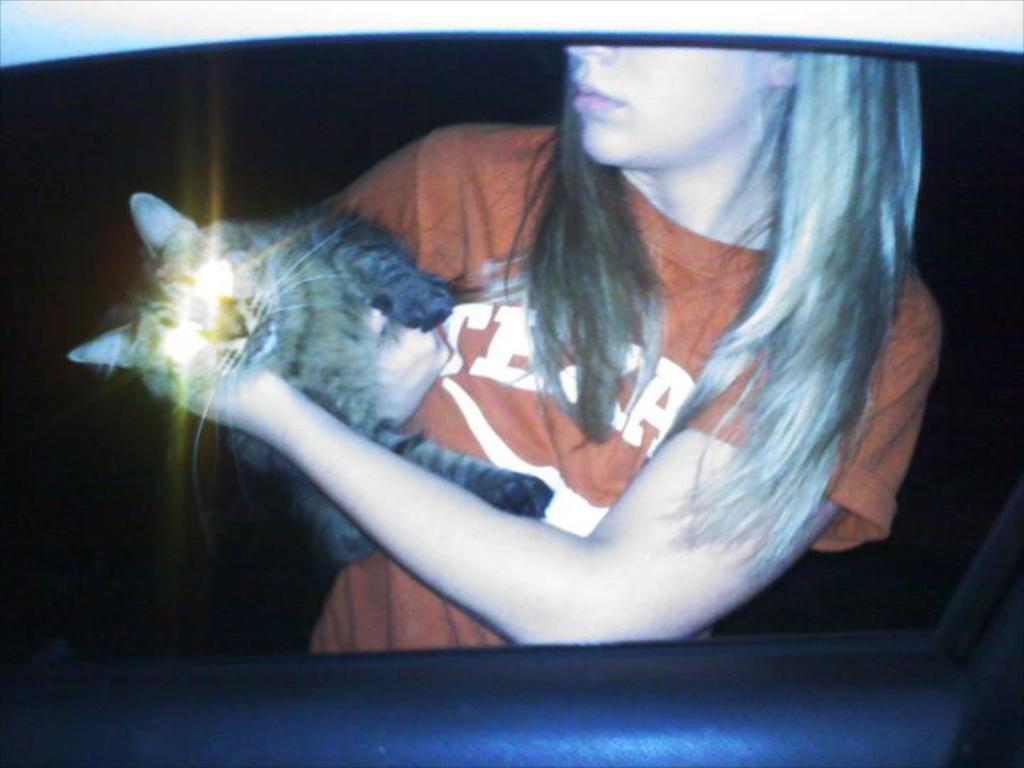Who is the main subject in the image? There is a girl in the image. What is the girl wearing? The girl is wearing a t-shirt. What is the girl holding in the image? The girl is holding a cat. Can you describe the lighting in the image? The scene takes place in the dark. What is the size of the zebra in the image? There is no zebra present in the image. 